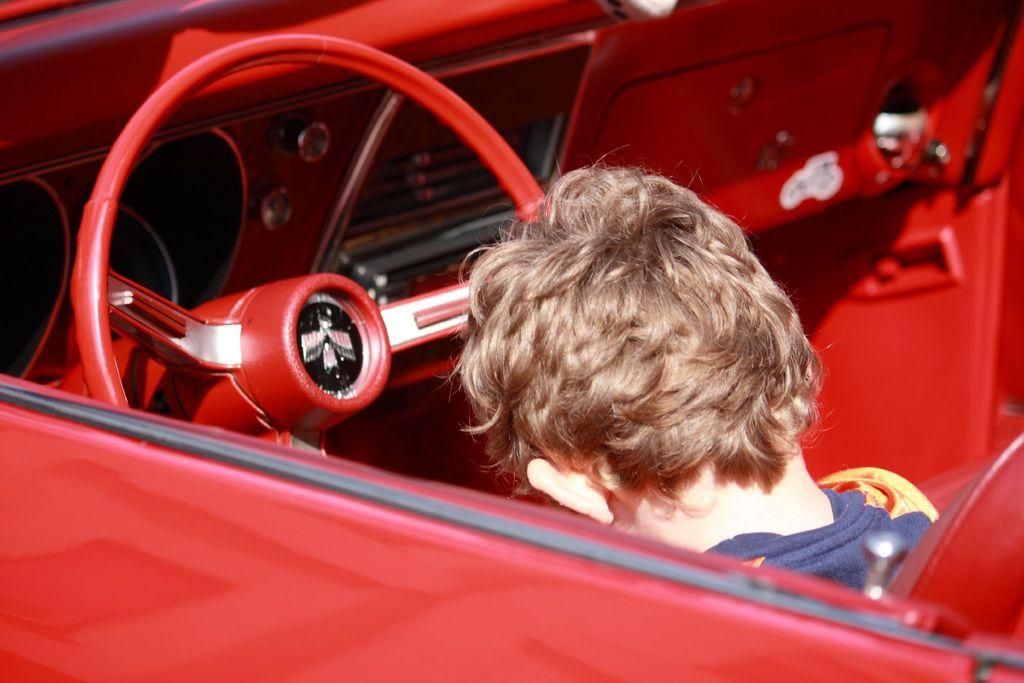What is the main subject of the image? The main subject of the image is a child. Where is the child located in the image? The child is in a vehicle. What is the color of the vehicle? The vehicle is red in color. What type of death is depicted in the image? There is no depiction of death in the image; it features a child in a red vehicle. What birthday celebration is taking place in the image? There is no birthday celebration present in the image. 